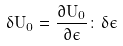Convert formula to latex. <formula><loc_0><loc_0><loc_500><loc_500>\delta U _ { 0 } = \frac { \partial U _ { 0 } } { \partial \epsilon } \colon \delta \epsilon</formula> 